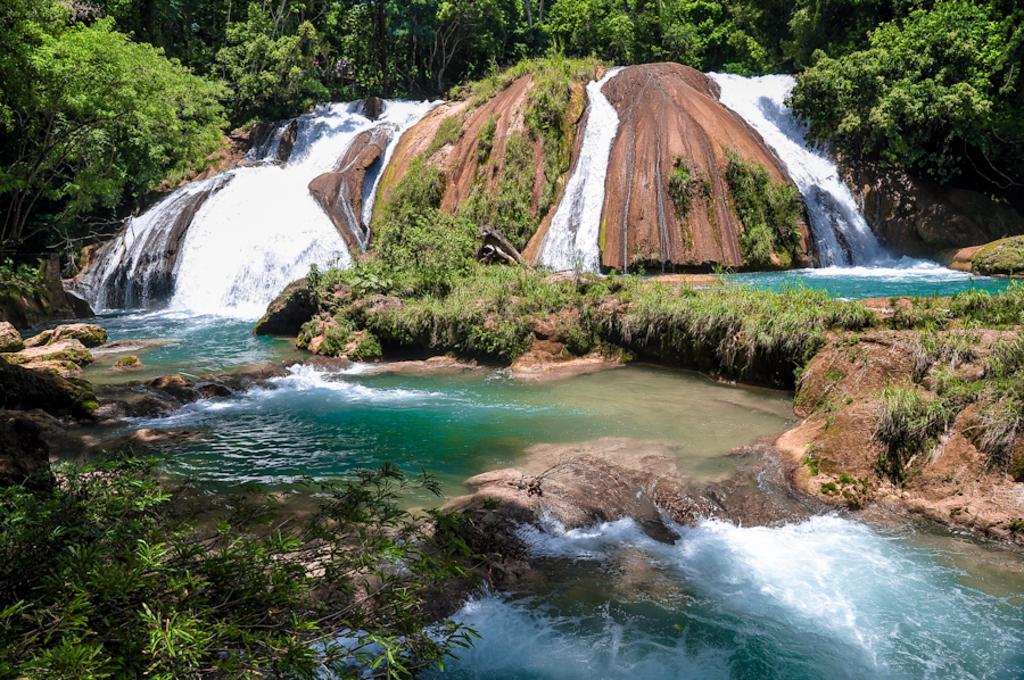Describe this image in one or two sentences. At the bottom of the image we can see some water and stones. In the middle of the image we can see some waterfall and trees. 